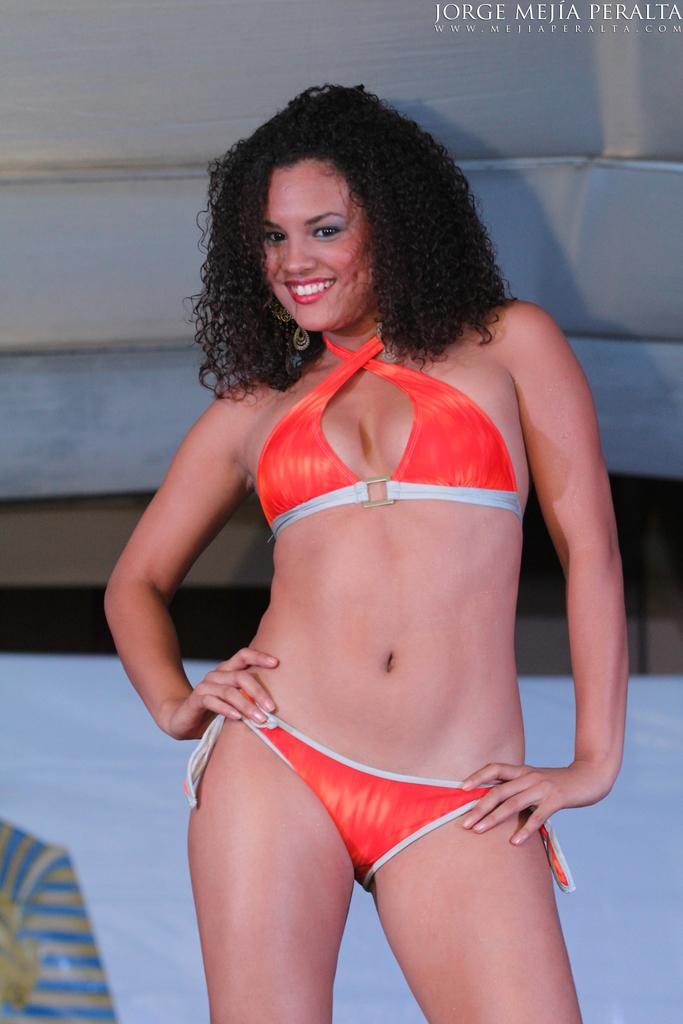Who is present in the image? There is a woman in the image. What is the woman doing in the image? The woman is standing and smiling. What can be seen in the background of the image? There is an object in the background of the image. What is visible in the top right of the image? There is text visible in the top right of the image. What type of pets can be seen fighting in the image? There are no pets or fighting depicted in the image. 